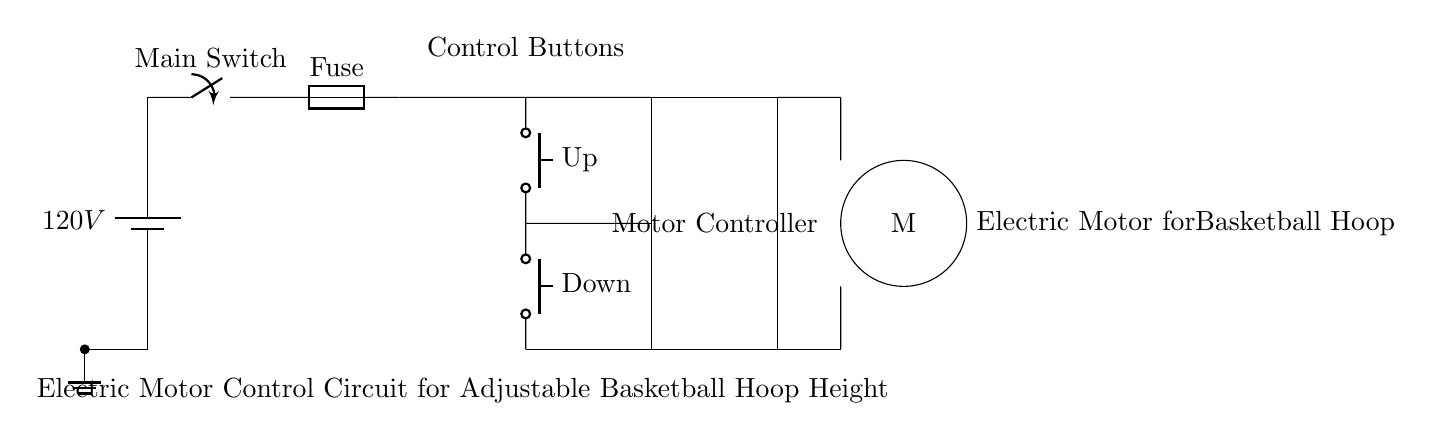What is the voltage source in this circuit? The circuit diagram shows a battery labeled with a voltage of 120V. This indicates the source of electrical energy for the entire circuit.
Answer: 120V What type of components are the buttons labeled "Up" and "Down"? The buttons labeled "Up" and "Down" are classified as push buttons, as indicated in the diagram. These components are generally used for controlling the operation of the motor.
Answer: Push buttons What does the rectangle in the circuit represent? The rectangle indicates a motor controller, which is responsible for controlling the speed and direction of the electric motor that adjusts the basketball hoop height.
Answer: Motor controller How many push buttons are included in the circuit? The diagram depicts two push buttons, one labeled "Up" and the other labeled "Down," which are used to control the raising and lowering of the basketball hoop.
Answer: Two What is the purpose of the fuse in this circuit? The fuse serves as a protective component that prevents excessive current from flowing through the circuit, which could potentially damage other components or cause a fire.
Answer: Protection What is the function of the electric motor in this circuit? The electric motor converts electrical energy from the circuit into mechanical energy, which is used to change the height of the basketball hoop.
Answer: Adjust hoop height What is the purpose of the main switch in the circuit? The main switch allows the user to turn the entire circuit on or off, effectively controlling the power supply to all components including the motor and the control buttons.
Answer: Control power 